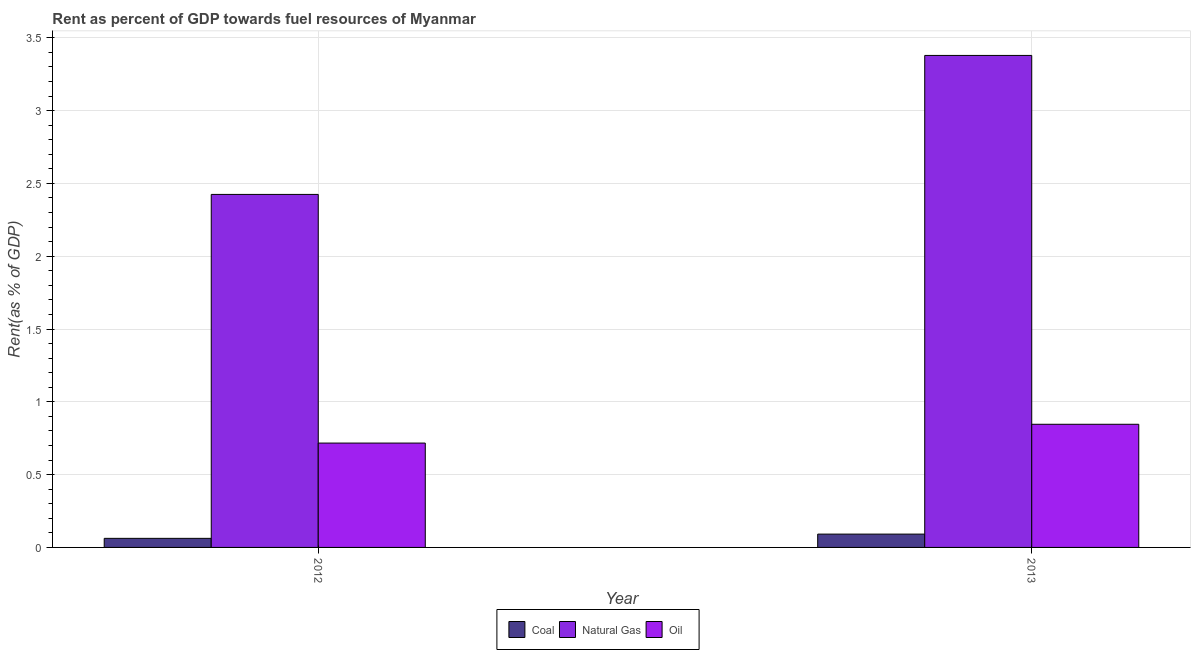Are the number of bars per tick equal to the number of legend labels?
Give a very brief answer. Yes. Are the number of bars on each tick of the X-axis equal?
Your answer should be very brief. Yes. How many bars are there on the 2nd tick from the left?
Offer a very short reply. 3. In how many cases, is the number of bars for a given year not equal to the number of legend labels?
Ensure brevity in your answer.  0. What is the rent towards oil in 2013?
Keep it short and to the point. 0.85. Across all years, what is the maximum rent towards coal?
Make the answer very short. 0.09. Across all years, what is the minimum rent towards coal?
Your answer should be very brief. 0.06. In which year was the rent towards coal maximum?
Offer a terse response. 2013. What is the total rent towards oil in the graph?
Offer a terse response. 1.56. What is the difference between the rent towards oil in 2012 and that in 2013?
Offer a terse response. -0.13. What is the difference between the rent towards natural gas in 2013 and the rent towards coal in 2012?
Your response must be concise. 0.95. What is the average rent towards natural gas per year?
Your answer should be compact. 2.9. In the year 2013, what is the difference between the rent towards coal and rent towards natural gas?
Ensure brevity in your answer.  0. What is the ratio of the rent towards coal in 2012 to that in 2013?
Ensure brevity in your answer.  0.68. Is the rent towards oil in 2012 less than that in 2013?
Provide a succinct answer. Yes. In how many years, is the rent towards oil greater than the average rent towards oil taken over all years?
Your response must be concise. 1. What does the 3rd bar from the left in 2013 represents?
Give a very brief answer. Oil. What does the 1st bar from the right in 2012 represents?
Provide a short and direct response. Oil. Is it the case that in every year, the sum of the rent towards coal and rent towards natural gas is greater than the rent towards oil?
Your answer should be very brief. Yes. Are all the bars in the graph horizontal?
Provide a succinct answer. No. How many years are there in the graph?
Your response must be concise. 2. What is the difference between two consecutive major ticks on the Y-axis?
Provide a short and direct response. 0.5. Does the graph contain grids?
Give a very brief answer. Yes. Where does the legend appear in the graph?
Ensure brevity in your answer.  Bottom center. How are the legend labels stacked?
Provide a succinct answer. Horizontal. What is the title of the graph?
Offer a terse response. Rent as percent of GDP towards fuel resources of Myanmar. What is the label or title of the X-axis?
Make the answer very short. Year. What is the label or title of the Y-axis?
Make the answer very short. Rent(as % of GDP). What is the Rent(as % of GDP) in Coal in 2012?
Provide a short and direct response. 0.06. What is the Rent(as % of GDP) of Natural Gas in 2012?
Your answer should be very brief. 2.42. What is the Rent(as % of GDP) in Oil in 2012?
Your answer should be compact. 0.72. What is the Rent(as % of GDP) in Coal in 2013?
Your answer should be compact. 0.09. What is the Rent(as % of GDP) in Natural Gas in 2013?
Offer a terse response. 3.38. What is the Rent(as % of GDP) of Oil in 2013?
Ensure brevity in your answer.  0.85. Across all years, what is the maximum Rent(as % of GDP) in Coal?
Give a very brief answer. 0.09. Across all years, what is the maximum Rent(as % of GDP) in Natural Gas?
Your answer should be very brief. 3.38. Across all years, what is the maximum Rent(as % of GDP) in Oil?
Ensure brevity in your answer.  0.85. Across all years, what is the minimum Rent(as % of GDP) of Coal?
Give a very brief answer. 0.06. Across all years, what is the minimum Rent(as % of GDP) in Natural Gas?
Your answer should be very brief. 2.42. Across all years, what is the minimum Rent(as % of GDP) of Oil?
Make the answer very short. 0.72. What is the total Rent(as % of GDP) in Coal in the graph?
Your response must be concise. 0.15. What is the total Rent(as % of GDP) of Natural Gas in the graph?
Keep it short and to the point. 5.8. What is the total Rent(as % of GDP) of Oil in the graph?
Your response must be concise. 1.56. What is the difference between the Rent(as % of GDP) of Coal in 2012 and that in 2013?
Provide a succinct answer. -0.03. What is the difference between the Rent(as % of GDP) of Natural Gas in 2012 and that in 2013?
Your response must be concise. -0.95. What is the difference between the Rent(as % of GDP) of Oil in 2012 and that in 2013?
Make the answer very short. -0.13. What is the difference between the Rent(as % of GDP) of Coal in 2012 and the Rent(as % of GDP) of Natural Gas in 2013?
Provide a short and direct response. -3.32. What is the difference between the Rent(as % of GDP) in Coal in 2012 and the Rent(as % of GDP) in Oil in 2013?
Give a very brief answer. -0.78. What is the difference between the Rent(as % of GDP) in Natural Gas in 2012 and the Rent(as % of GDP) in Oil in 2013?
Provide a succinct answer. 1.58. What is the average Rent(as % of GDP) in Coal per year?
Ensure brevity in your answer.  0.08. What is the average Rent(as % of GDP) in Natural Gas per year?
Your answer should be very brief. 2.9. What is the average Rent(as % of GDP) in Oil per year?
Keep it short and to the point. 0.78. In the year 2012, what is the difference between the Rent(as % of GDP) of Coal and Rent(as % of GDP) of Natural Gas?
Your answer should be very brief. -2.36. In the year 2012, what is the difference between the Rent(as % of GDP) of Coal and Rent(as % of GDP) of Oil?
Keep it short and to the point. -0.65. In the year 2012, what is the difference between the Rent(as % of GDP) in Natural Gas and Rent(as % of GDP) in Oil?
Keep it short and to the point. 1.71. In the year 2013, what is the difference between the Rent(as % of GDP) in Coal and Rent(as % of GDP) in Natural Gas?
Give a very brief answer. -3.29. In the year 2013, what is the difference between the Rent(as % of GDP) of Coal and Rent(as % of GDP) of Oil?
Keep it short and to the point. -0.75. In the year 2013, what is the difference between the Rent(as % of GDP) in Natural Gas and Rent(as % of GDP) in Oil?
Your answer should be very brief. 2.53. What is the ratio of the Rent(as % of GDP) of Coal in 2012 to that in 2013?
Keep it short and to the point. 0.68. What is the ratio of the Rent(as % of GDP) in Natural Gas in 2012 to that in 2013?
Give a very brief answer. 0.72. What is the ratio of the Rent(as % of GDP) of Oil in 2012 to that in 2013?
Keep it short and to the point. 0.85. What is the difference between the highest and the second highest Rent(as % of GDP) in Coal?
Ensure brevity in your answer.  0.03. What is the difference between the highest and the second highest Rent(as % of GDP) in Natural Gas?
Provide a succinct answer. 0.95. What is the difference between the highest and the second highest Rent(as % of GDP) in Oil?
Offer a terse response. 0.13. What is the difference between the highest and the lowest Rent(as % of GDP) of Coal?
Provide a short and direct response. 0.03. What is the difference between the highest and the lowest Rent(as % of GDP) of Natural Gas?
Give a very brief answer. 0.95. What is the difference between the highest and the lowest Rent(as % of GDP) in Oil?
Provide a short and direct response. 0.13. 